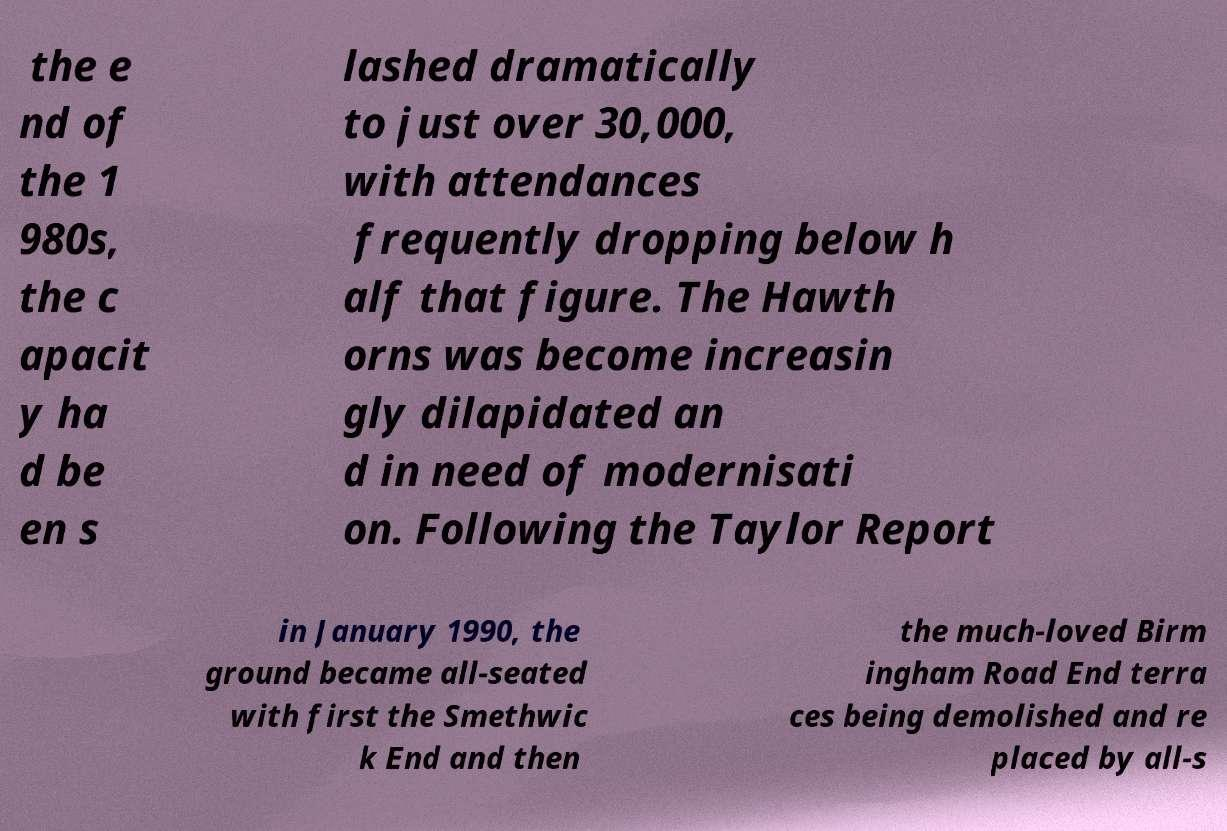Please read and relay the text visible in this image. What does it say? the e nd of the 1 980s, the c apacit y ha d be en s lashed dramatically to just over 30,000, with attendances frequently dropping below h alf that figure. The Hawth orns was become increasin gly dilapidated an d in need of modernisati on. Following the Taylor Report in January 1990, the ground became all-seated with first the Smethwic k End and then the much-loved Birm ingham Road End terra ces being demolished and re placed by all-s 